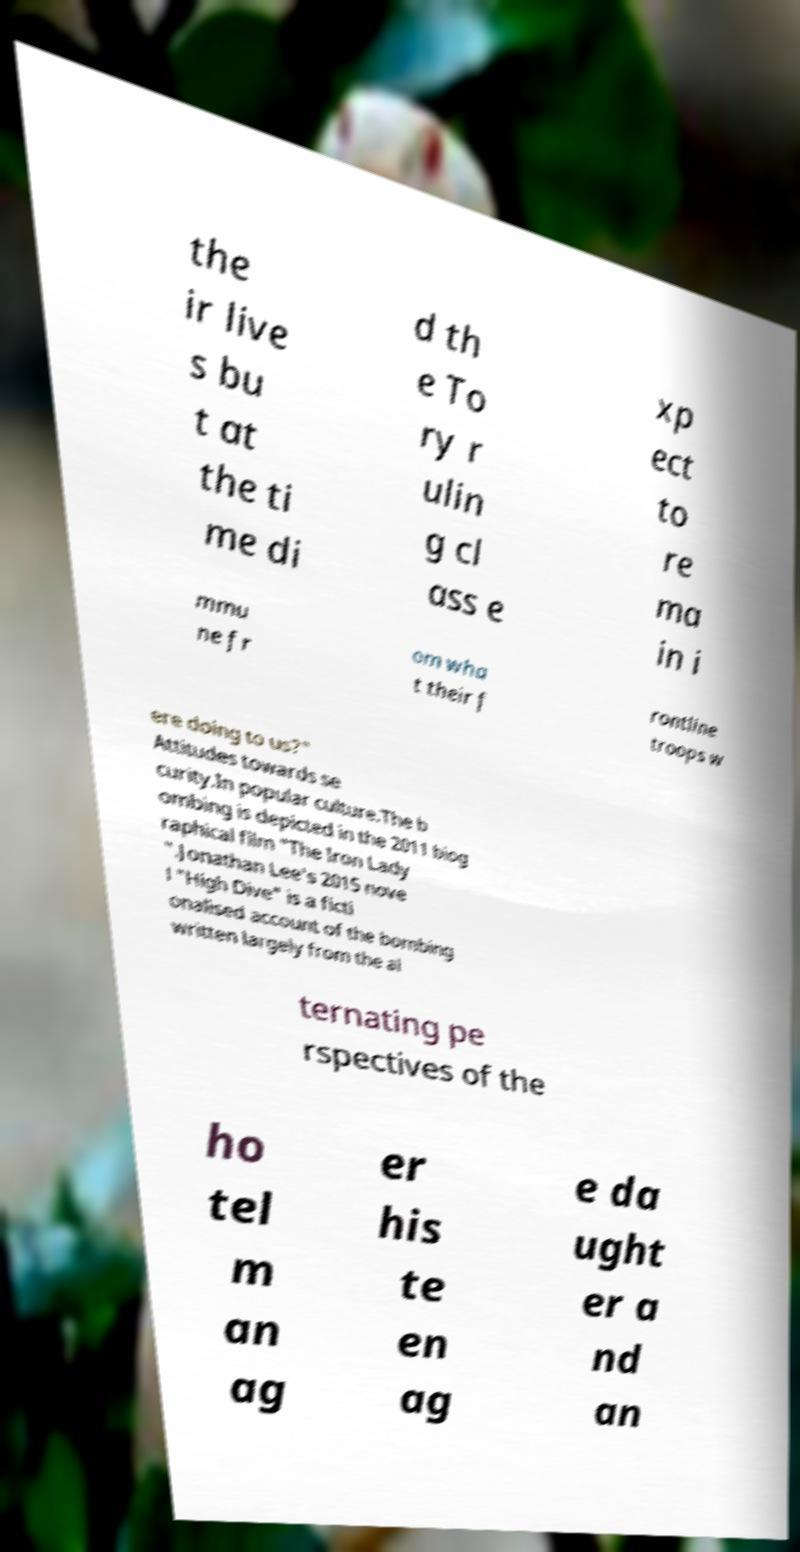Can you accurately transcribe the text from the provided image for me? the ir live s bu t at the ti me di d th e To ry r ulin g cl ass e xp ect to re ma in i mmu ne fr om wha t their f rontline troops w ere doing to us?" Attitudes towards se curity.In popular culture.The b ombing is depicted in the 2011 biog raphical film "The Iron Lady ".Jonathan Lee's 2015 nove l "High Dive" is a ficti onalised account of the bombing written largely from the al ternating pe rspectives of the ho tel m an ag er his te en ag e da ught er a nd an 